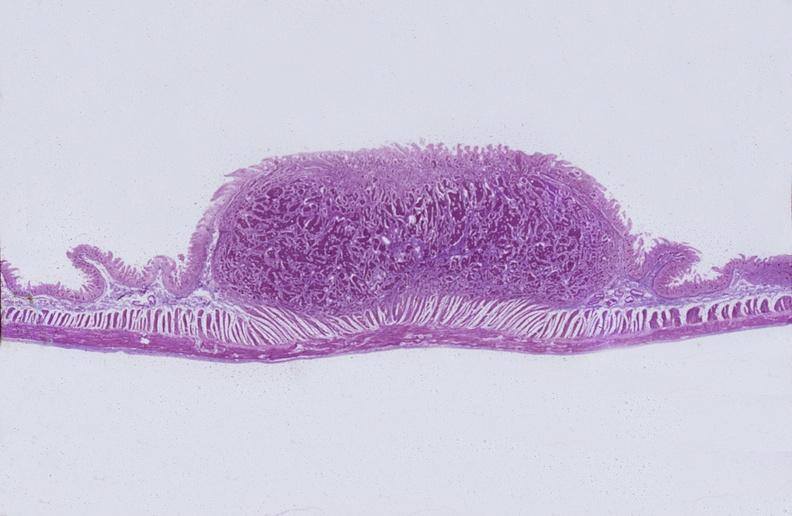does thyroid show intestine, carcinoid tumor?
Answer the question using a single word or phrase. No 